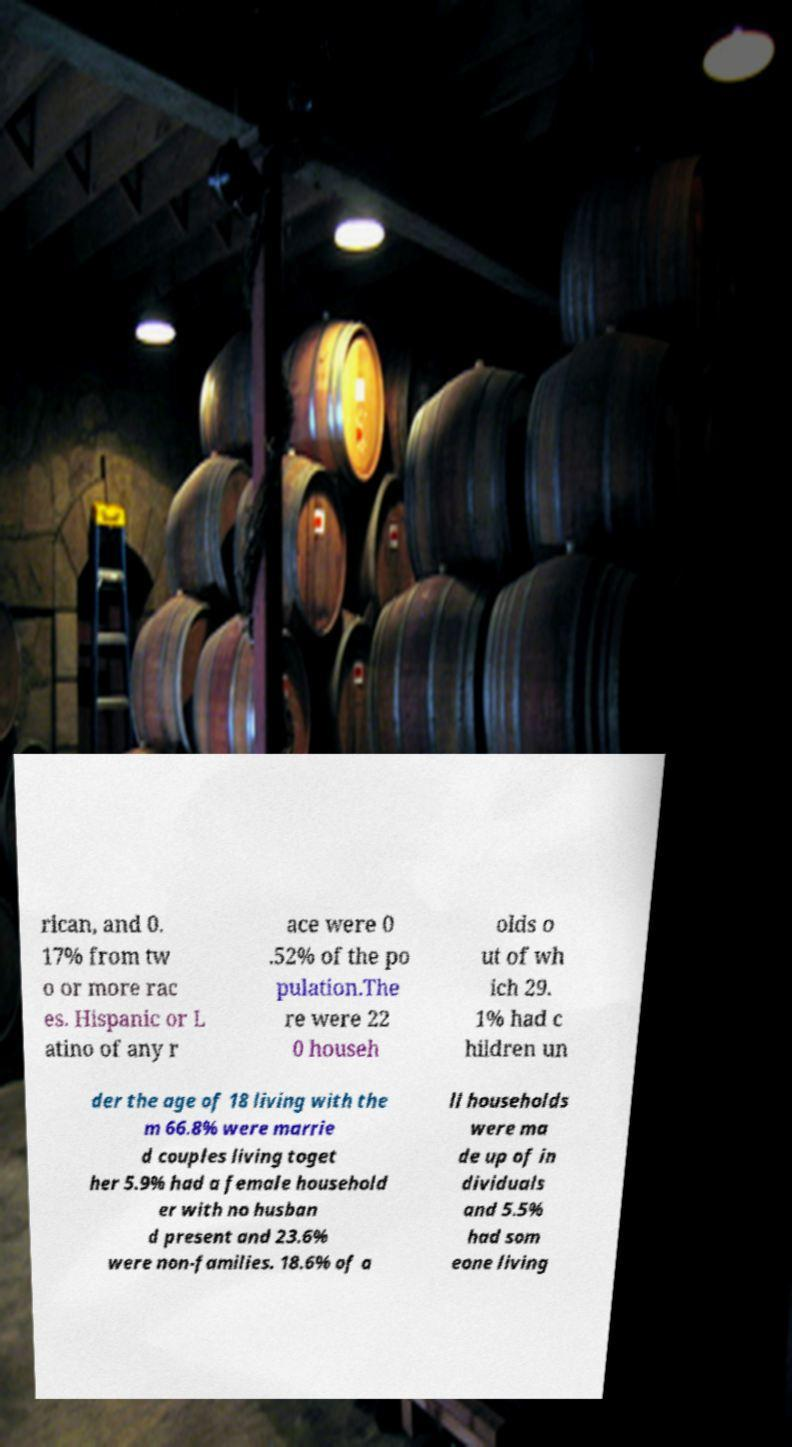What messages or text are displayed in this image? I need them in a readable, typed format. rican, and 0. 17% from tw o or more rac es. Hispanic or L atino of any r ace were 0 .52% of the po pulation.The re were 22 0 househ olds o ut of wh ich 29. 1% had c hildren un der the age of 18 living with the m 66.8% were marrie d couples living toget her 5.9% had a female household er with no husban d present and 23.6% were non-families. 18.6% of a ll households were ma de up of in dividuals and 5.5% had som eone living 